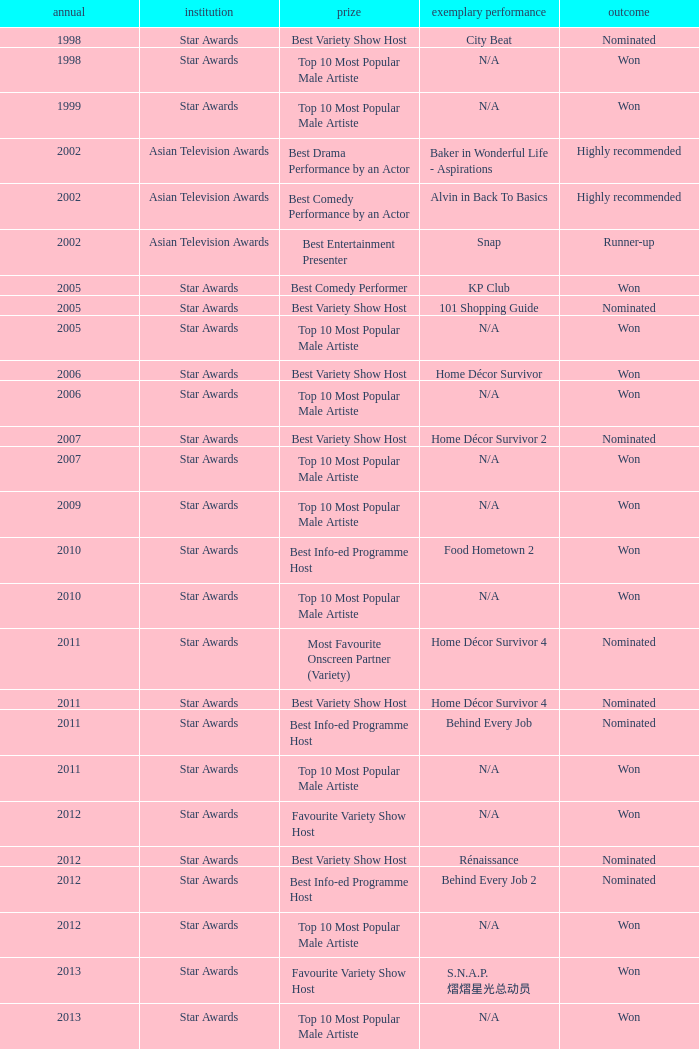What is the organisation in 2011 that was nominated and the award of best info-ed programme host? Star Awards. 